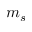<formula> <loc_0><loc_0><loc_500><loc_500>m _ { s }</formula> 